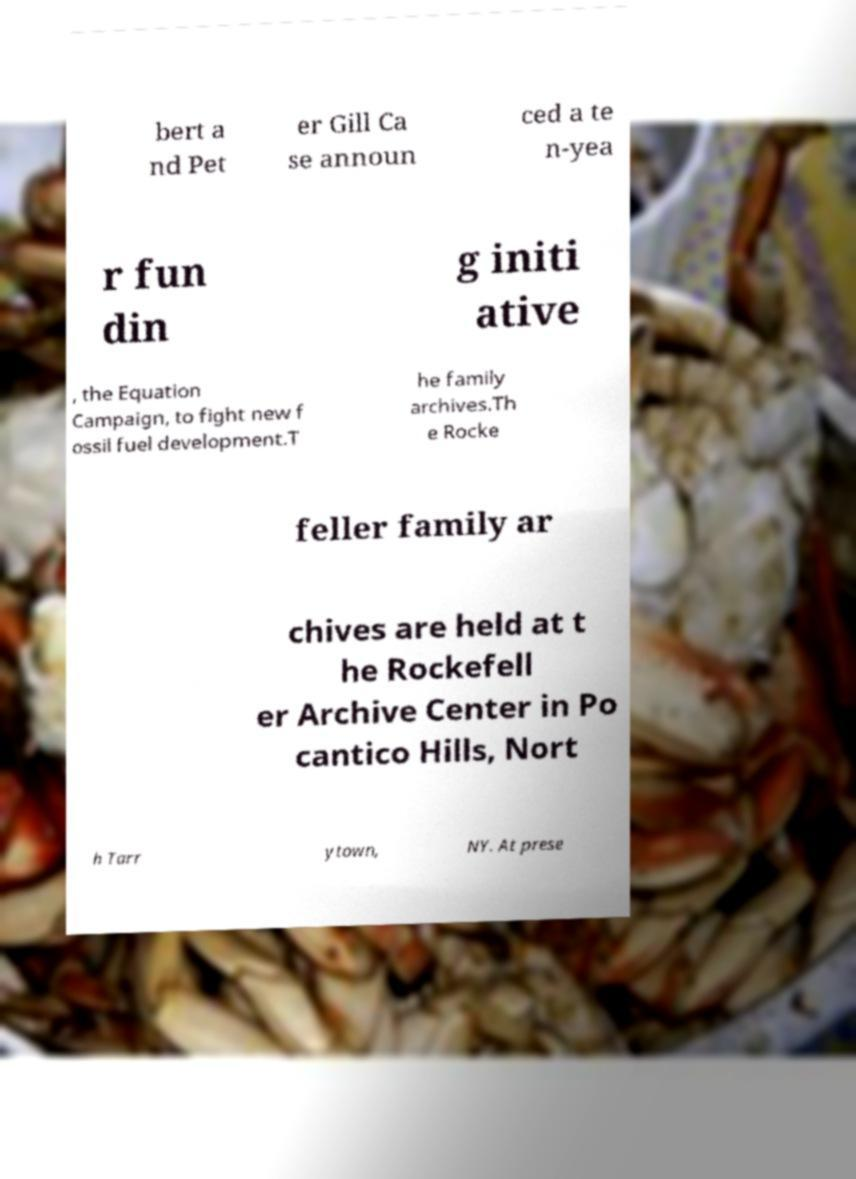Please read and relay the text visible in this image. What does it say? bert a nd Pet er Gill Ca se announ ced a te n-yea r fun din g initi ative , the Equation Campaign, to fight new f ossil fuel development.T he family archives.Th e Rocke feller family ar chives are held at t he Rockefell er Archive Center in Po cantico Hills, Nort h Tarr ytown, NY. At prese 